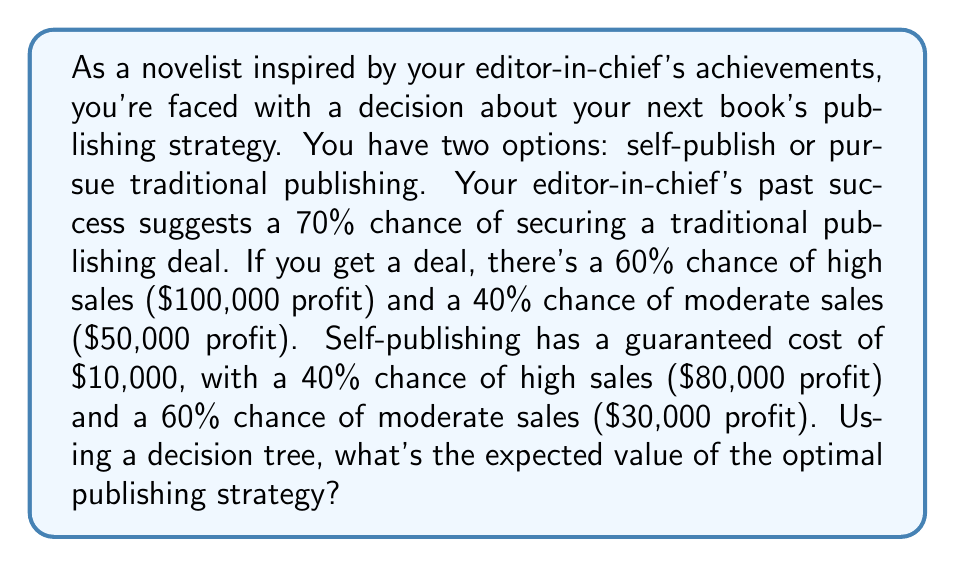Can you answer this question? Let's approach this problem step-by-step using a decision tree:

1. First, let's outline the two main branches of our decision tree:
   a) Traditional Publishing
   b) Self-Publishing

2. For Traditional Publishing:
   - 70% chance of securing a deal
   - 30% chance of rejection (resulting in $0 profit)
   
   If a deal is secured:
   - 60% chance of high sales: $100,000
   - 40% chance of moderate sales: $50,000

3. For Self-Publishing:
   - Guaranteed cost of $10,000
   - 40% chance of high sales: $80,000
   - 60% chance of moderate sales: $30,000

4. Let's calculate the expected value (EV) for each path:

   Traditional Publishing:
   $$EV_{traditional} = 0.7 \times (0.6 \times 100,000 + 0.4 \times 50,000) + 0.3 \times 0$$
   $$EV_{traditional} = 0.7 \times (60,000 + 20,000) + 0$$
   $$EV_{traditional} = 0.7 \times 80,000 = 56,000$$

   Self-Publishing:
   $$EV_{self} = -10,000 + (0.4 \times 80,000 + 0.6 \times 30,000)$$
   $$EV_{self} = -10,000 + (32,000 + 18,000)$$
   $$EV_{self} = -10,000 + 50,000 = 40,000$$

5. Compare the expected values:
   Traditional Publishing EV: $56,000
   Self-Publishing EV: $40,000

The optimal strategy is the one with the higher expected value.
Answer: The optimal publishing strategy is Traditional Publishing, with an expected value of $56,000. 